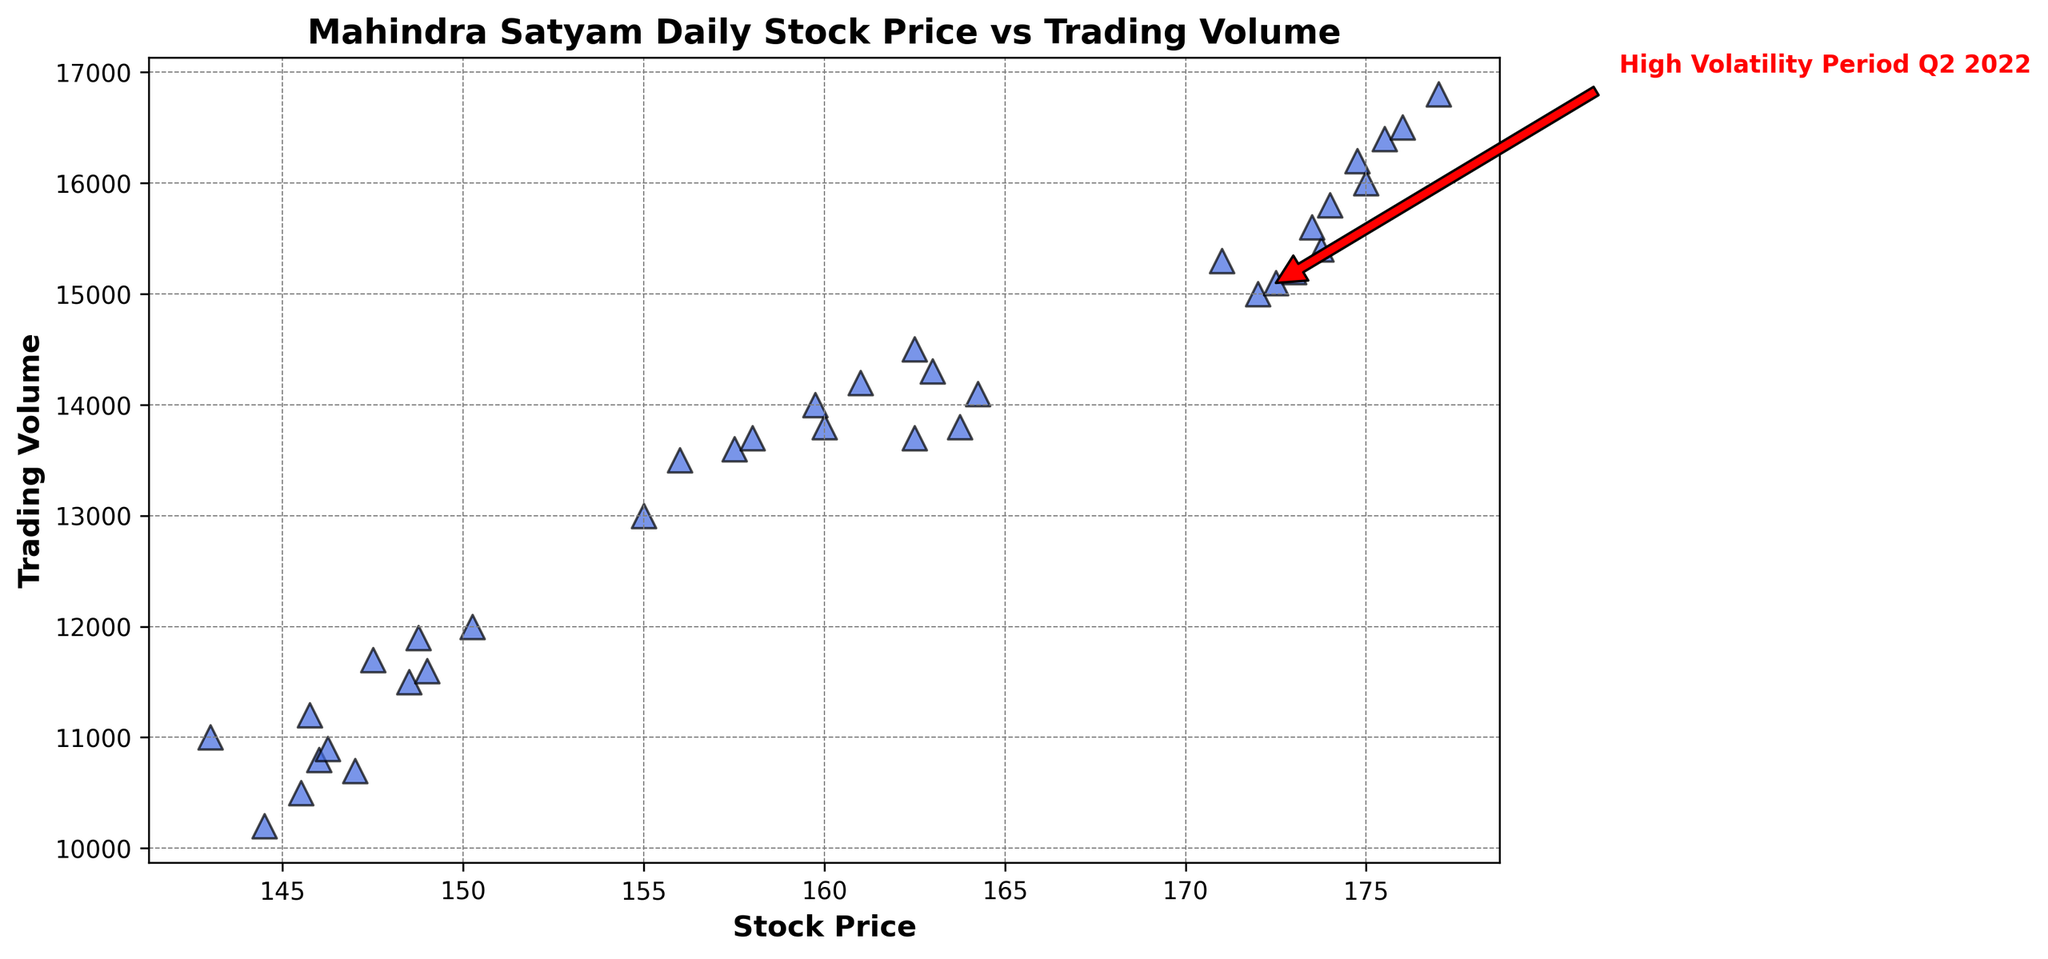How does the trading volume vary with the stock price in the scatter plot? By observing the scatter plot, you can see each point's position; higher trading volumes generally correspond with higher stock prices. For example, points with stock prices above 170 tend to have trading volumes around or above 15000.
Answer: Higher trading volumes generally occur with higher stock prices During which date period is the "High Volatility Period Q2 2022" annotation marked? The annotation is marked around the data point on July 1, 2022, which depicts both a high increase in stock price and trading volume. The annotation points to a noticeable position in the scatter plot with an arrow and a label indicating this period.
Answer: July 1, 2022 What is the general relationship between stock price and trading volume as shown in the scatter plot? Typically, as the stock price increases, the trading volume also increases, as depicted by the upward trend of the scatter plot points from left to right.
Answer: Positive correlation Which stock price has the highest associated trading volume in the scatter plot? Identify the point with the highest position on the vertical axis (trading volume). By comparing all points, the highest trading volume is observed slightly above 16800 at the stock price of 177 on July 12, 2022.
Answer: 177 Identify the scatter plot point associated with the highest trading volume and the specific annotation added in the plot. The point corresponding to the highest trading volume is at a stock price of 177 with a trading volume of around 16800. The annotation for "High Volatility Period Q2 2022" can be seen at a stock price of 172 and a trading volume around 15000 on July 01, 2022.
Answer: 172 (High Volatility Period), 177 (Highest Trading Volume) Compare the trading volume of the stock price at 173 and 148.5. Which one is higher? Find the points corresponding to stock prices 173 and 148.5 on the horizontal axis. The point for 173 has a higher trading volume around 15200, whereas the point for 148.5 has a trading volume around 11500.
Answer: 173 What stock price corresponds to the highest trading volume in the scatter plot? By looking at the point positioned at the maximum value on the trading volume axis, you observe that the highest trading volume (around 16800) corresponds with the stock price of 177.
Answer: 177 How does the trading volume for the date identified as the "High Volatility Period Q2 2022" (July 1, 2022) compare to the trading volume on January 1, 2022? Locate the trading volume for July 1, 2022 (around 15000) and compare it directly with January 1, 2022 (around 10500). The trading volume is significantly higher on July 1, 2022.
Answer: Higher on July 1, 2022 What is the trading volume for the highest price point shown in the scatter plot? Identify the highest price point on the horizontal axis, which is 177, and check its corresponding trading volume on the vertical axis (around 16800).
Answer: 16800 